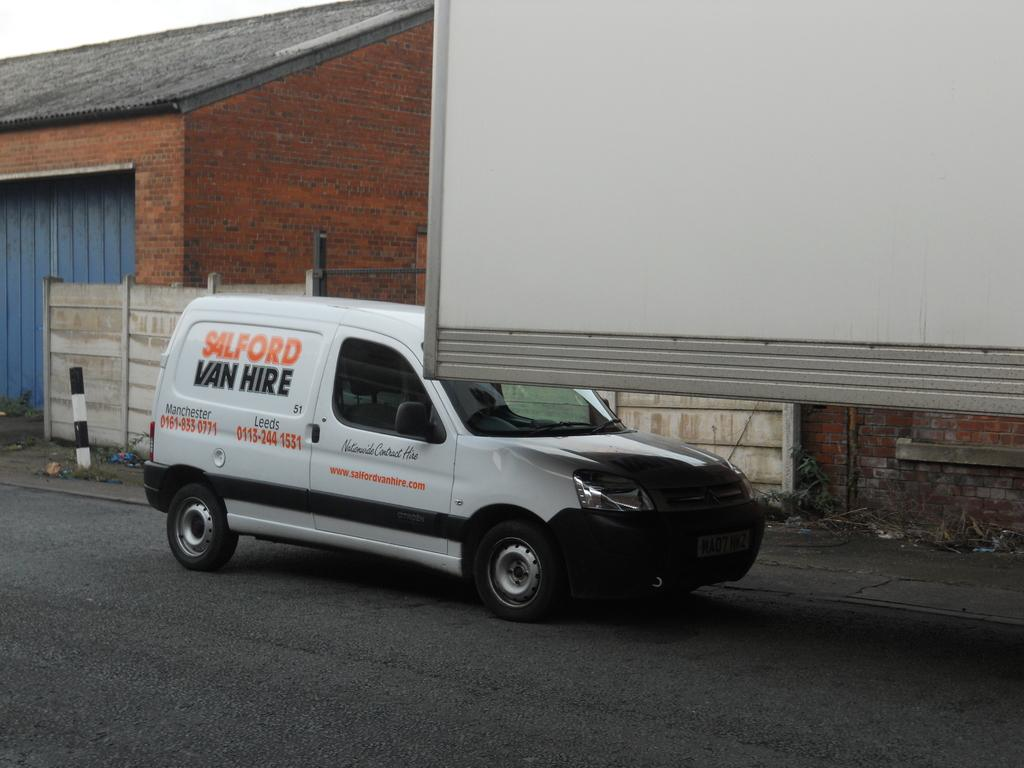Provide a one-sentence caption for the provided image. A white Sailford Van Lines van is parked next to a trailer in front of a brick building. 